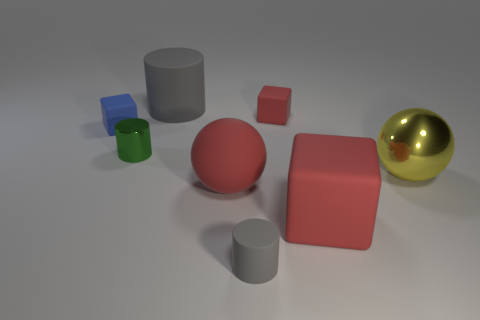Add 2 tiny red matte balls. How many objects exist? 10 Subtract all blocks. How many objects are left? 5 Subtract 1 red balls. How many objects are left? 7 Subtract all metal cylinders. Subtract all large gray cylinders. How many objects are left? 6 Add 8 big cylinders. How many big cylinders are left? 9 Add 3 small gray rubber cylinders. How many small gray rubber cylinders exist? 4 